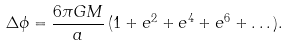Convert formula to latex. <formula><loc_0><loc_0><loc_500><loc_500>\Delta \phi = \frac { 6 \pi G M } { a } \, ( 1 + e ^ { 2 } + e ^ { 4 } + e ^ { 6 } + \dots ) .</formula> 